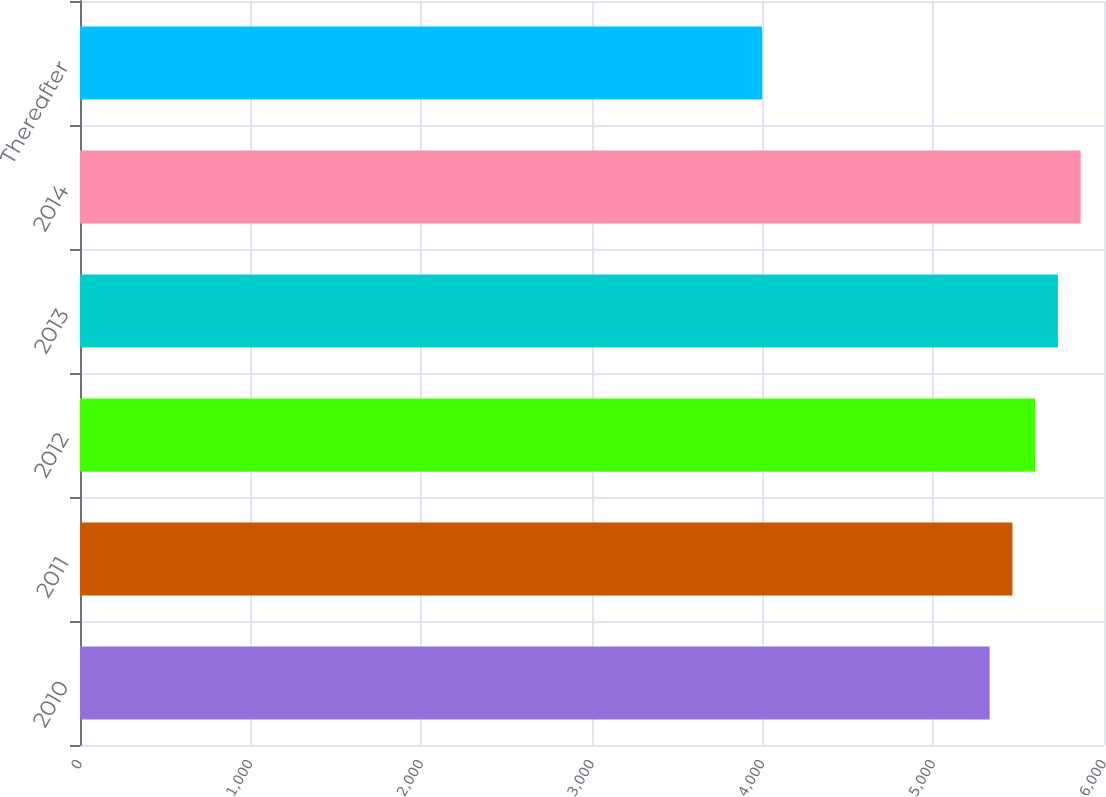<chart> <loc_0><loc_0><loc_500><loc_500><bar_chart><fcel>2010<fcel>2011<fcel>2012<fcel>2013<fcel>2014<fcel>Thereafter<nl><fcel>5330<fcel>5463.3<fcel>5596.6<fcel>5729.9<fcel>5863.2<fcel>3997<nl></chart> 